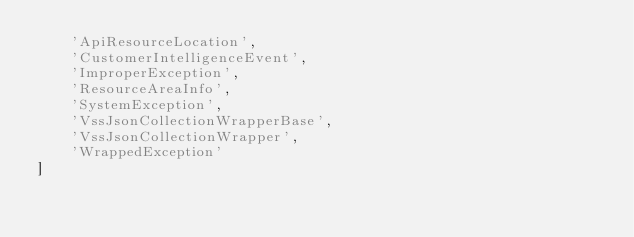Convert code to text. <code><loc_0><loc_0><loc_500><loc_500><_Python_>    'ApiResourceLocation',
    'CustomerIntelligenceEvent',
    'ImproperException',
    'ResourceAreaInfo',
    'SystemException',
    'VssJsonCollectionWrapperBase',
    'VssJsonCollectionWrapper',
    'WrappedException'
]
</code> 